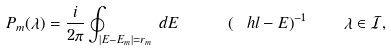Convert formula to latex. <formula><loc_0><loc_0><loc_500><loc_500>P _ { m } ( \lambda ) = \frac { i } { 2 \pi } \oint _ { | E - E _ { m } | = r _ { m } } \, d E \quad \ \left ( \ h l - E \right ) ^ { - 1 } \quad \lambda \in \mathcal { I } ,</formula> 